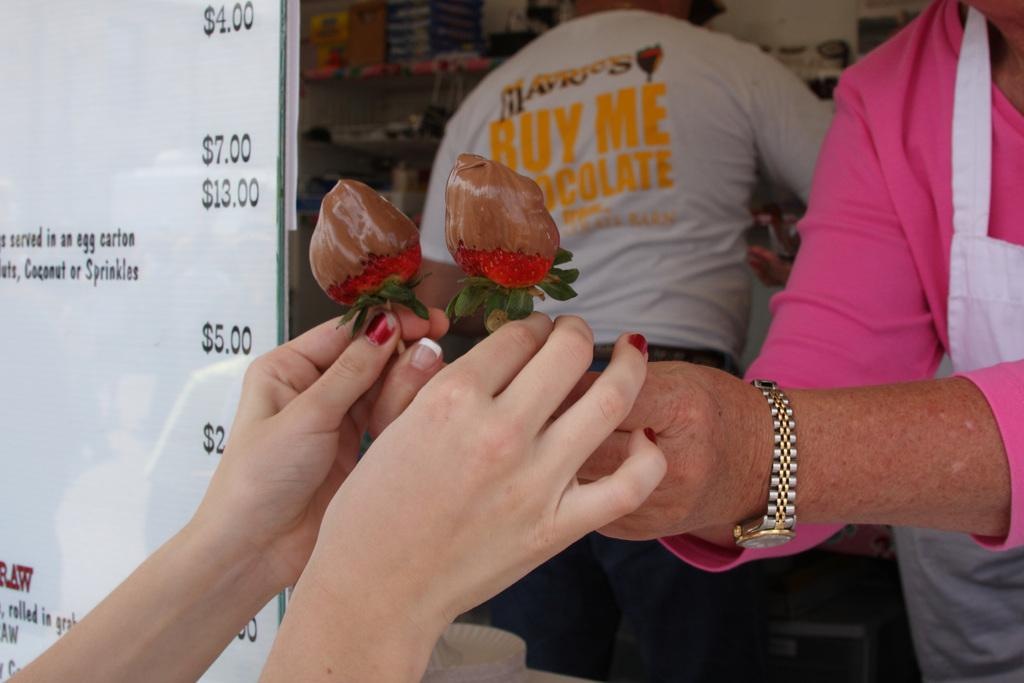How many people are present in the image? There are three people in the image. What are two of the people doing with their hands? Two of the people are holding food items. What can be seen on the board in the image? There is text and numbers on the board in the image. What type of storage is visible in the image? There are boxes on racks in the image. What is the angle of the birth in the image? There is no birth present in the image, so it is not possible to determine the angle of a birth. 